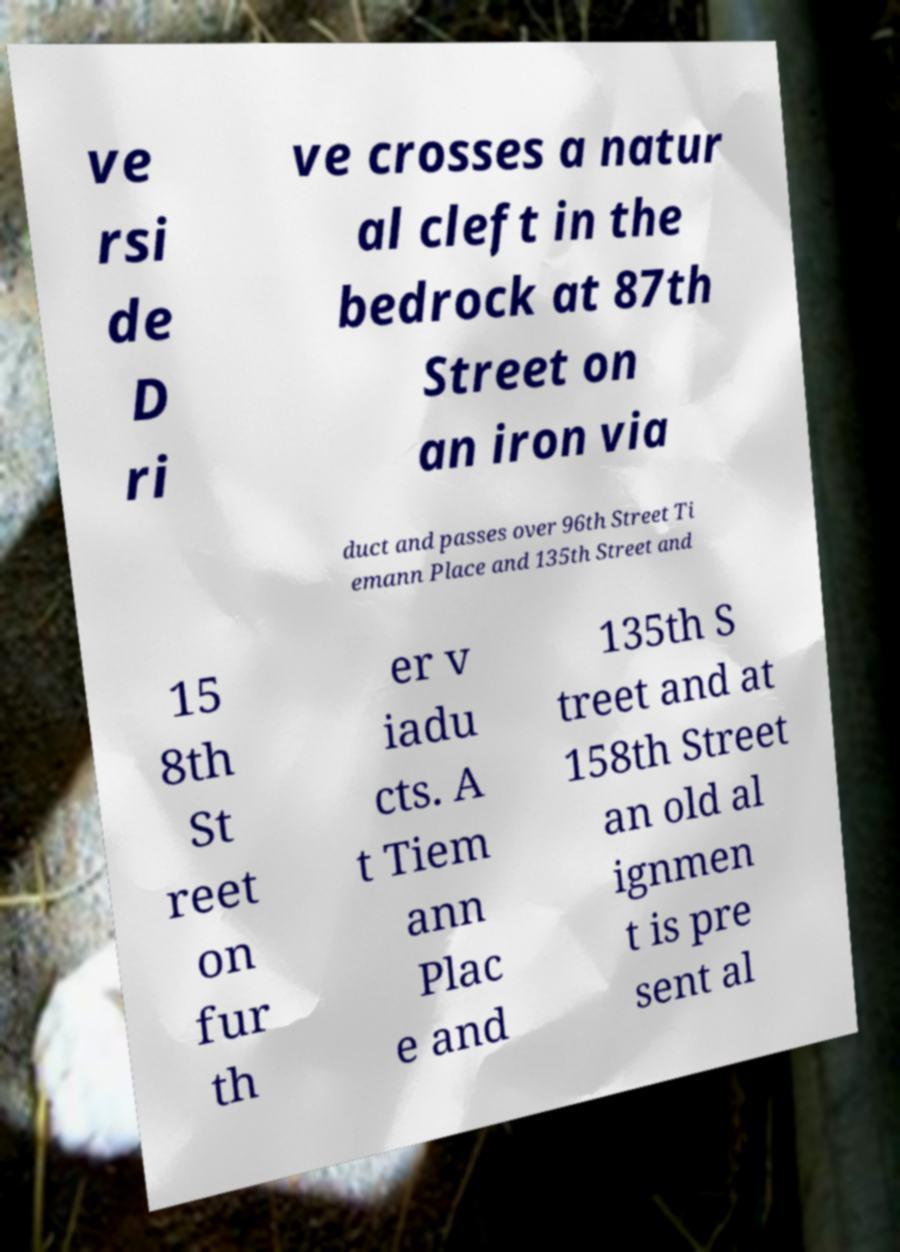Please read and relay the text visible in this image. What does it say? ve rsi de D ri ve crosses a natur al cleft in the bedrock at 87th Street on an iron via duct and passes over 96th Street Ti emann Place and 135th Street and 15 8th St reet on fur th er v iadu cts. A t Tiem ann Plac e and 135th S treet and at 158th Street an old al ignmen t is pre sent al 